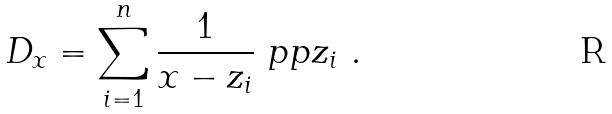<formula> <loc_0><loc_0><loc_500><loc_500>D _ { x } = \sum _ { i = 1 } ^ { n } \frac { 1 } { x - z _ { i } } \ p p { z _ { i } } \ .</formula> 